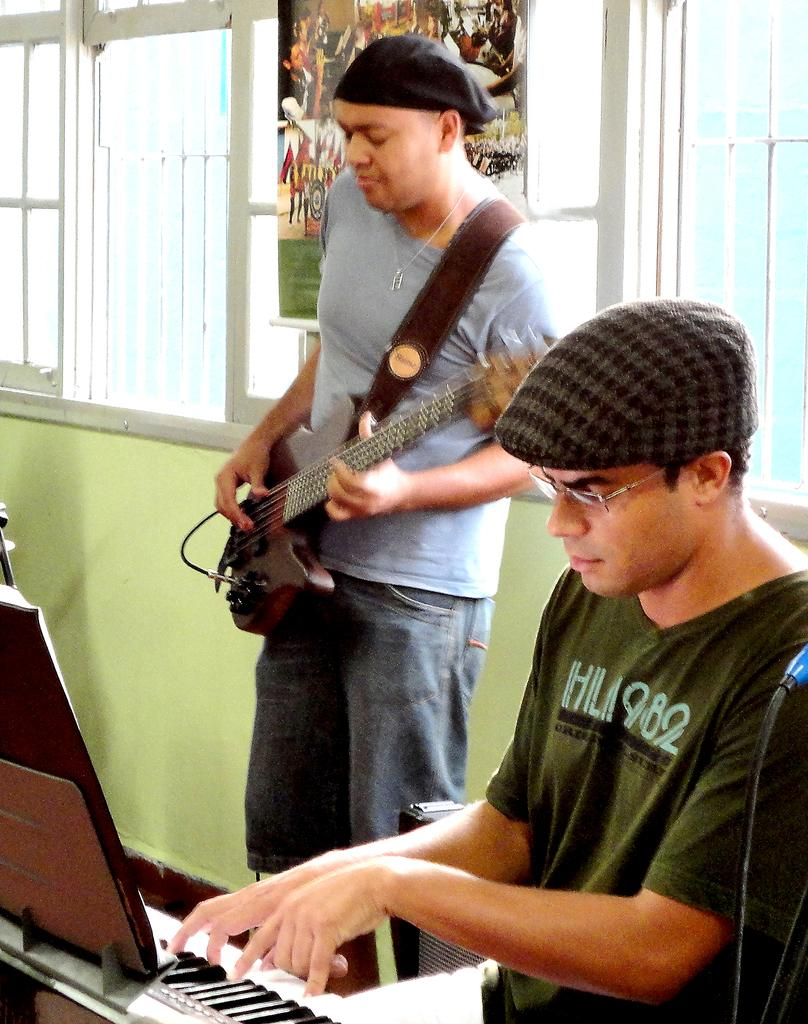What is the man in the image doing? There is a man playing guitar in the image. Can you describe the man's attire? The man is wearing a cap. Are there any other musicians in the image? Yes, there is a man playing piano in the image. What can be seen in the background of the image? There is a wall and a window in the background of the image. How many kittens are sitting on the man's head in the image? There are no kittens present in the image, so it is not possible to answer that question. 